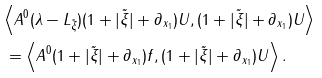Convert formula to latex. <formula><loc_0><loc_0><loc_500><loc_500>& \left \langle A ^ { 0 } ( \lambda - L _ { \tilde { \xi } } ) ( 1 + | \tilde { \xi } | + \partial _ { x _ { 1 } } ) U , ( 1 + | \tilde { \xi } | + \partial _ { x _ { 1 } } ) U \right \rangle \\ & \, = \left \langle A ^ { 0 } ( 1 + | \tilde { \xi } | + \partial _ { x _ { 1 } } ) f , ( 1 + | \tilde { \xi } | + \partial _ { x _ { 1 } } ) U \right \rangle .</formula> 